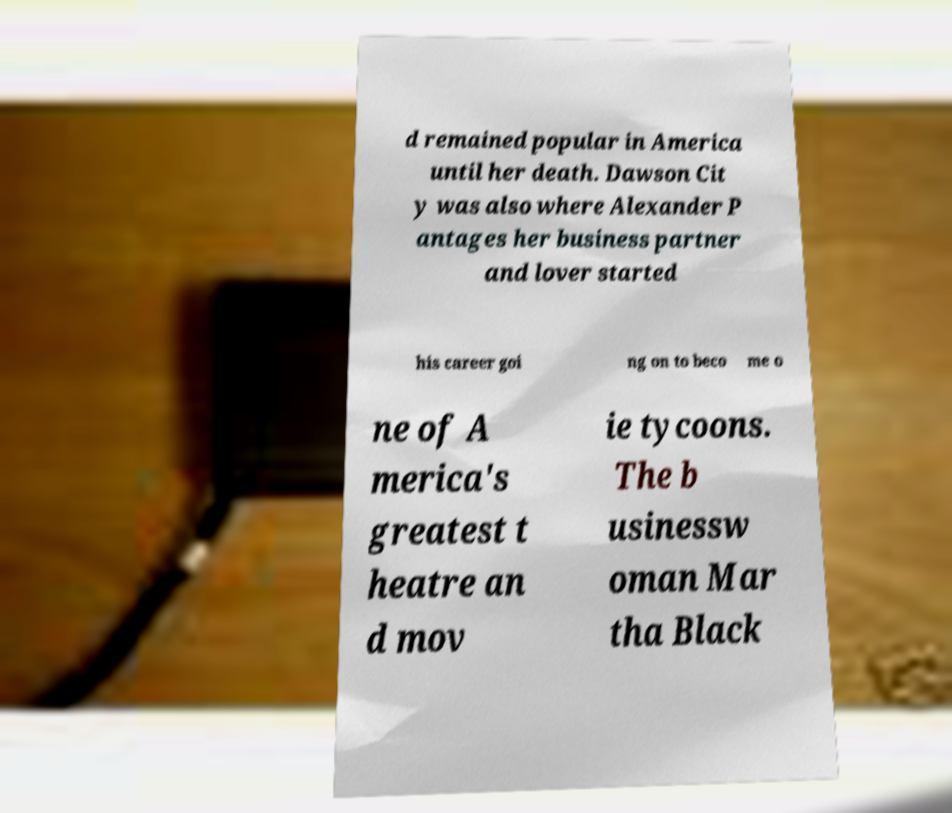Can you read and provide the text displayed in the image?This photo seems to have some interesting text. Can you extract and type it out for me? d remained popular in America until her death. Dawson Cit y was also where Alexander P antages her business partner and lover started his career goi ng on to beco me o ne of A merica's greatest t heatre an d mov ie tycoons. The b usinessw oman Mar tha Black 